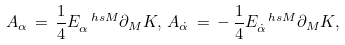Convert formula to latex. <formula><loc_0><loc_0><loc_500><loc_500>A _ { \alpha } \, = \, \frac { 1 } { 4 } E _ { \alpha } ^ { \ h s M } \partial _ { M } K , \, A _ { \dot { \alpha } } \, = \, - \, \frac { 1 } { 4 } E _ { \dot { \alpha } } ^ { \ h s M } \partial _ { M } K ,</formula> 